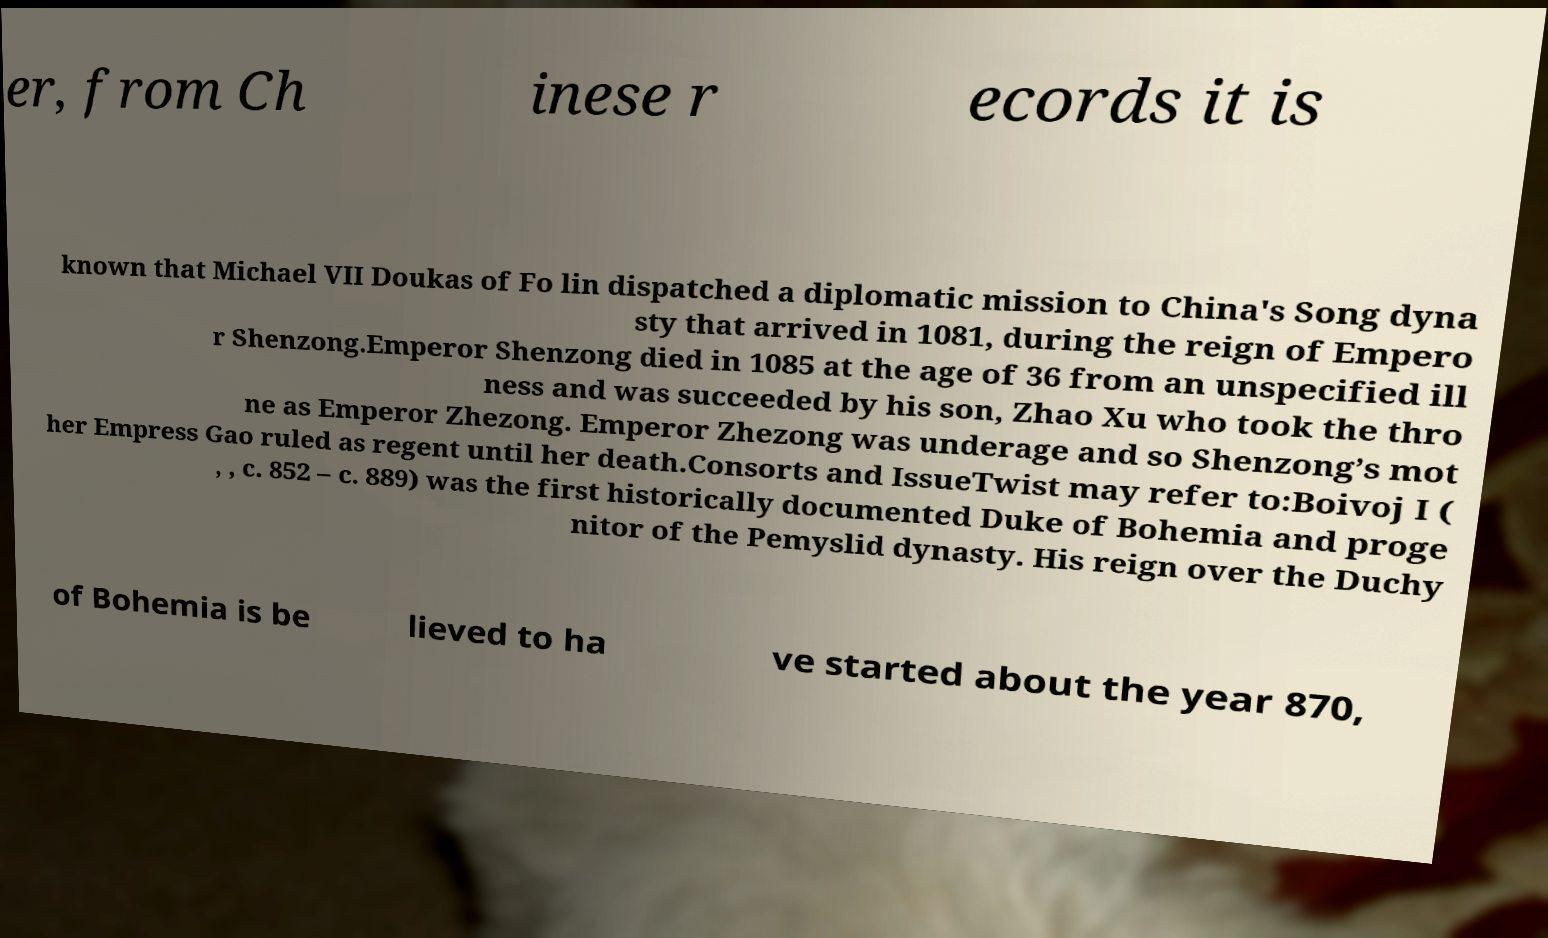For documentation purposes, I need the text within this image transcribed. Could you provide that? er, from Ch inese r ecords it is known that Michael VII Doukas of Fo lin dispatched a diplomatic mission to China's Song dyna sty that arrived in 1081, during the reign of Empero r Shenzong.Emperor Shenzong died in 1085 at the age of 36 from an unspecified ill ness and was succeeded by his son, Zhao Xu who took the thro ne as Emperor Zhezong. Emperor Zhezong was underage and so Shenzong’s mot her Empress Gao ruled as regent until her death.Consorts and IssueTwist may refer to:Boivoj I ( , , c. 852 – c. 889) was the first historically documented Duke of Bohemia and proge nitor of the Pemyslid dynasty. His reign over the Duchy of Bohemia is be lieved to ha ve started about the year 870, 